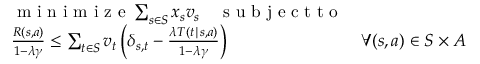<formula> <loc_0><loc_0><loc_500><loc_500>\begin{array} { r l r } & { \min i m i z e \sum _ { s \in S } x _ { s } v _ { s } \quad s u b j e c t t o } \\ & { \frac { R ( s , a ) } { 1 - \lambda \gamma } \leq \sum _ { t \in S } v _ { t } \left ( \delta _ { s , t } - \frac { \lambda T ( t | s , a ) } { 1 - \lambda \gamma } \right ) } & { \forall ( s , a ) \in S \times A } \end{array}</formula> 